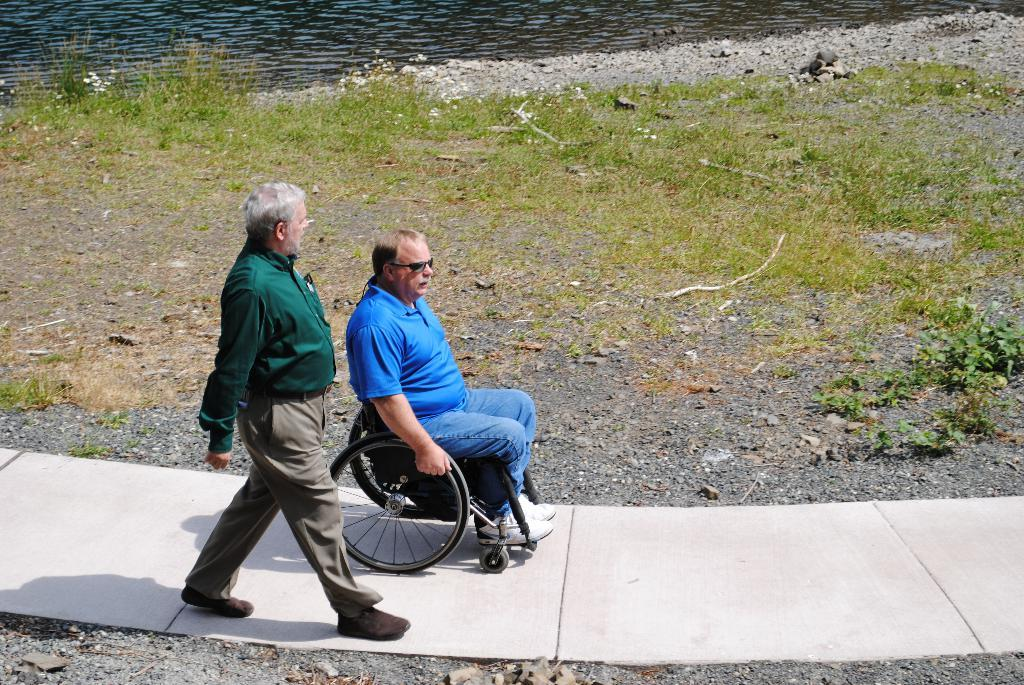How many people are in the image? There are two people in the image. What is the condition of one of the people in the image? One person is sitting on a wheelchair. What is the other person doing in the image? The other person is walking. What type of terrain is visible in the image? There is grass in the image. What can be seen in the background of the image? There is water visible at the top of the image. What type of breath does the judge take in the image? There is no judge present in the image, and therefore no such action can be observed. 